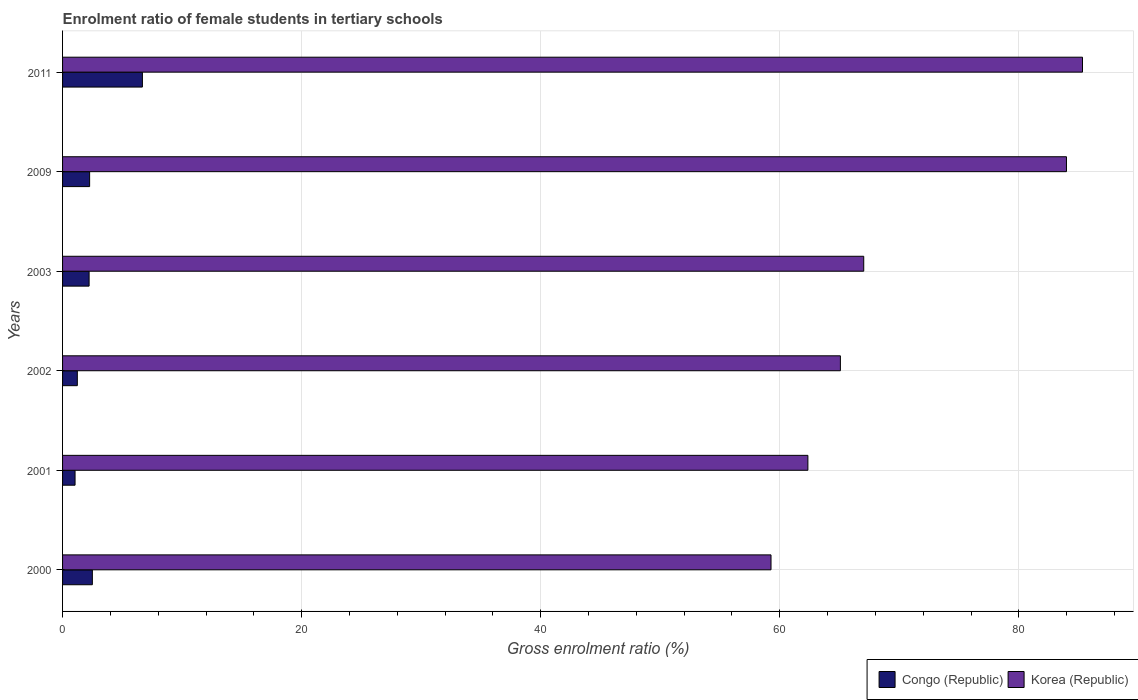How many different coloured bars are there?
Your answer should be compact. 2. How many groups of bars are there?
Your answer should be very brief. 6. Are the number of bars per tick equal to the number of legend labels?
Make the answer very short. Yes. Are the number of bars on each tick of the Y-axis equal?
Keep it short and to the point. Yes. How many bars are there on the 3rd tick from the bottom?
Make the answer very short. 2. What is the label of the 5th group of bars from the top?
Provide a succinct answer. 2001. In how many cases, is the number of bars for a given year not equal to the number of legend labels?
Provide a short and direct response. 0. What is the enrolment ratio of female students in tertiary schools in Congo (Republic) in 2011?
Provide a short and direct response. 6.68. Across all years, what is the maximum enrolment ratio of female students in tertiary schools in Congo (Republic)?
Keep it short and to the point. 6.68. Across all years, what is the minimum enrolment ratio of female students in tertiary schools in Congo (Republic)?
Offer a terse response. 1.04. What is the total enrolment ratio of female students in tertiary schools in Congo (Republic) in the graph?
Offer a terse response. 15.93. What is the difference between the enrolment ratio of female students in tertiary schools in Congo (Republic) in 2000 and that in 2003?
Offer a very short reply. 0.27. What is the difference between the enrolment ratio of female students in tertiary schools in Korea (Republic) in 2009 and the enrolment ratio of female students in tertiary schools in Congo (Republic) in 2003?
Keep it short and to the point. 81.76. What is the average enrolment ratio of female students in tertiary schools in Korea (Republic) per year?
Your response must be concise. 70.5. In the year 2002, what is the difference between the enrolment ratio of female students in tertiary schools in Korea (Republic) and enrolment ratio of female students in tertiary schools in Congo (Republic)?
Your response must be concise. 63.83. What is the ratio of the enrolment ratio of female students in tertiary schools in Korea (Republic) in 2002 to that in 2009?
Keep it short and to the point. 0.77. Is the enrolment ratio of female students in tertiary schools in Congo (Republic) in 2001 less than that in 2009?
Your answer should be compact. Yes. Is the difference between the enrolment ratio of female students in tertiary schools in Korea (Republic) in 2000 and 2009 greater than the difference between the enrolment ratio of female students in tertiary schools in Congo (Republic) in 2000 and 2009?
Your response must be concise. No. What is the difference between the highest and the second highest enrolment ratio of female students in tertiary schools in Congo (Republic)?
Ensure brevity in your answer.  4.19. What is the difference between the highest and the lowest enrolment ratio of female students in tertiary schools in Korea (Republic)?
Your answer should be very brief. 26.06. In how many years, is the enrolment ratio of female students in tertiary schools in Congo (Republic) greater than the average enrolment ratio of female students in tertiary schools in Congo (Republic) taken over all years?
Provide a short and direct response. 1. Is the sum of the enrolment ratio of female students in tertiary schools in Congo (Republic) in 2001 and 2009 greater than the maximum enrolment ratio of female students in tertiary schools in Korea (Republic) across all years?
Provide a succinct answer. No. What does the 2nd bar from the bottom in 2003 represents?
Offer a terse response. Korea (Republic). How many bars are there?
Your response must be concise. 12. How many years are there in the graph?
Keep it short and to the point. 6. What is the difference between two consecutive major ticks on the X-axis?
Give a very brief answer. 20. Are the values on the major ticks of X-axis written in scientific E-notation?
Your answer should be compact. No. Does the graph contain any zero values?
Provide a short and direct response. No. Does the graph contain grids?
Your answer should be very brief. Yes. Where does the legend appear in the graph?
Your answer should be very brief. Bottom right. How many legend labels are there?
Give a very brief answer. 2. How are the legend labels stacked?
Ensure brevity in your answer.  Horizontal. What is the title of the graph?
Provide a succinct answer. Enrolment ratio of female students in tertiary schools. Does "Monaco" appear as one of the legend labels in the graph?
Offer a terse response. No. What is the label or title of the X-axis?
Your answer should be compact. Gross enrolment ratio (%). What is the Gross enrolment ratio (%) in Congo (Republic) in 2000?
Keep it short and to the point. 2.49. What is the Gross enrolment ratio (%) in Korea (Republic) in 2000?
Offer a very short reply. 59.26. What is the Gross enrolment ratio (%) in Congo (Republic) in 2001?
Your answer should be compact. 1.04. What is the Gross enrolment ratio (%) in Korea (Republic) in 2001?
Provide a short and direct response. 62.35. What is the Gross enrolment ratio (%) in Congo (Republic) in 2002?
Offer a terse response. 1.23. What is the Gross enrolment ratio (%) of Korea (Republic) in 2002?
Provide a short and direct response. 65.07. What is the Gross enrolment ratio (%) in Congo (Republic) in 2003?
Make the answer very short. 2.22. What is the Gross enrolment ratio (%) of Korea (Republic) in 2003?
Your answer should be very brief. 67.02. What is the Gross enrolment ratio (%) of Congo (Republic) in 2009?
Provide a succinct answer. 2.26. What is the Gross enrolment ratio (%) of Korea (Republic) in 2009?
Give a very brief answer. 83.98. What is the Gross enrolment ratio (%) of Congo (Republic) in 2011?
Offer a very short reply. 6.68. What is the Gross enrolment ratio (%) in Korea (Republic) in 2011?
Offer a very short reply. 85.32. Across all years, what is the maximum Gross enrolment ratio (%) in Congo (Republic)?
Offer a very short reply. 6.68. Across all years, what is the maximum Gross enrolment ratio (%) of Korea (Republic)?
Give a very brief answer. 85.32. Across all years, what is the minimum Gross enrolment ratio (%) in Congo (Republic)?
Provide a succinct answer. 1.04. Across all years, what is the minimum Gross enrolment ratio (%) of Korea (Republic)?
Provide a succinct answer. 59.26. What is the total Gross enrolment ratio (%) of Congo (Republic) in the graph?
Give a very brief answer. 15.93. What is the total Gross enrolment ratio (%) of Korea (Republic) in the graph?
Give a very brief answer. 423.01. What is the difference between the Gross enrolment ratio (%) of Congo (Republic) in 2000 and that in 2001?
Offer a very short reply. 1.45. What is the difference between the Gross enrolment ratio (%) in Korea (Republic) in 2000 and that in 2001?
Offer a terse response. -3.08. What is the difference between the Gross enrolment ratio (%) of Congo (Republic) in 2000 and that in 2002?
Make the answer very short. 1.26. What is the difference between the Gross enrolment ratio (%) in Korea (Republic) in 2000 and that in 2002?
Keep it short and to the point. -5.8. What is the difference between the Gross enrolment ratio (%) of Congo (Republic) in 2000 and that in 2003?
Your answer should be very brief. 0.27. What is the difference between the Gross enrolment ratio (%) in Korea (Republic) in 2000 and that in 2003?
Provide a short and direct response. -7.76. What is the difference between the Gross enrolment ratio (%) of Congo (Republic) in 2000 and that in 2009?
Provide a short and direct response. 0.23. What is the difference between the Gross enrolment ratio (%) of Korea (Republic) in 2000 and that in 2009?
Your response must be concise. -24.72. What is the difference between the Gross enrolment ratio (%) in Congo (Republic) in 2000 and that in 2011?
Ensure brevity in your answer.  -4.19. What is the difference between the Gross enrolment ratio (%) in Korea (Republic) in 2000 and that in 2011?
Make the answer very short. -26.06. What is the difference between the Gross enrolment ratio (%) of Congo (Republic) in 2001 and that in 2002?
Provide a succinct answer. -0.19. What is the difference between the Gross enrolment ratio (%) in Korea (Republic) in 2001 and that in 2002?
Provide a succinct answer. -2.72. What is the difference between the Gross enrolment ratio (%) in Congo (Republic) in 2001 and that in 2003?
Provide a succinct answer. -1.18. What is the difference between the Gross enrolment ratio (%) in Korea (Republic) in 2001 and that in 2003?
Give a very brief answer. -4.67. What is the difference between the Gross enrolment ratio (%) of Congo (Republic) in 2001 and that in 2009?
Your answer should be very brief. -1.22. What is the difference between the Gross enrolment ratio (%) of Korea (Republic) in 2001 and that in 2009?
Give a very brief answer. -21.63. What is the difference between the Gross enrolment ratio (%) in Congo (Republic) in 2001 and that in 2011?
Your answer should be very brief. -5.63. What is the difference between the Gross enrolment ratio (%) of Korea (Republic) in 2001 and that in 2011?
Keep it short and to the point. -22.97. What is the difference between the Gross enrolment ratio (%) of Congo (Republic) in 2002 and that in 2003?
Keep it short and to the point. -0.99. What is the difference between the Gross enrolment ratio (%) of Korea (Republic) in 2002 and that in 2003?
Offer a terse response. -1.95. What is the difference between the Gross enrolment ratio (%) in Congo (Republic) in 2002 and that in 2009?
Offer a very short reply. -1.03. What is the difference between the Gross enrolment ratio (%) in Korea (Republic) in 2002 and that in 2009?
Provide a succinct answer. -18.91. What is the difference between the Gross enrolment ratio (%) in Congo (Republic) in 2002 and that in 2011?
Offer a terse response. -5.44. What is the difference between the Gross enrolment ratio (%) of Korea (Republic) in 2002 and that in 2011?
Ensure brevity in your answer.  -20.25. What is the difference between the Gross enrolment ratio (%) of Congo (Republic) in 2003 and that in 2009?
Provide a short and direct response. -0.04. What is the difference between the Gross enrolment ratio (%) in Korea (Republic) in 2003 and that in 2009?
Your response must be concise. -16.96. What is the difference between the Gross enrolment ratio (%) in Congo (Republic) in 2003 and that in 2011?
Your response must be concise. -4.46. What is the difference between the Gross enrolment ratio (%) of Korea (Republic) in 2003 and that in 2011?
Ensure brevity in your answer.  -18.3. What is the difference between the Gross enrolment ratio (%) of Congo (Republic) in 2009 and that in 2011?
Offer a terse response. -4.42. What is the difference between the Gross enrolment ratio (%) in Korea (Republic) in 2009 and that in 2011?
Keep it short and to the point. -1.34. What is the difference between the Gross enrolment ratio (%) of Congo (Republic) in 2000 and the Gross enrolment ratio (%) of Korea (Republic) in 2001?
Offer a terse response. -59.86. What is the difference between the Gross enrolment ratio (%) in Congo (Republic) in 2000 and the Gross enrolment ratio (%) in Korea (Republic) in 2002?
Provide a short and direct response. -62.58. What is the difference between the Gross enrolment ratio (%) in Congo (Republic) in 2000 and the Gross enrolment ratio (%) in Korea (Republic) in 2003?
Provide a short and direct response. -64.53. What is the difference between the Gross enrolment ratio (%) in Congo (Republic) in 2000 and the Gross enrolment ratio (%) in Korea (Republic) in 2009?
Offer a terse response. -81.49. What is the difference between the Gross enrolment ratio (%) of Congo (Republic) in 2000 and the Gross enrolment ratio (%) of Korea (Republic) in 2011?
Provide a succinct answer. -82.83. What is the difference between the Gross enrolment ratio (%) of Congo (Republic) in 2001 and the Gross enrolment ratio (%) of Korea (Republic) in 2002?
Provide a short and direct response. -64.02. What is the difference between the Gross enrolment ratio (%) of Congo (Republic) in 2001 and the Gross enrolment ratio (%) of Korea (Republic) in 2003?
Your answer should be compact. -65.98. What is the difference between the Gross enrolment ratio (%) of Congo (Republic) in 2001 and the Gross enrolment ratio (%) of Korea (Republic) in 2009?
Make the answer very short. -82.94. What is the difference between the Gross enrolment ratio (%) of Congo (Republic) in 2001 and the Gross enrolment ratio (%) of Korea (Republic) in 2011?
Offer a very short reply. -84.28. What is the difference between the Gross enrolment ratio (%) of Congo (Republic) in 2002 and the Gross enrolment ratio (%) of Korea (Republic) in 2003?
Provide a short and direct response. -65.79. What is the difference between the Gross enrolment ratio (%) of Congo (Republic) in 2002 and the Gross enrolment ratio (%) of Korea (Republic) in 2009?
Your response must be concise. -82.75. What is the difference between the Gross enrolment ratio (%) in Congo (Republic) in 2002 and the Gross enrolment ratio (%) in Korea (Republic) in 2011?
Give a very brief answer. -84.09. What is the difference between the Gross enrolment ratio (%) in Congo (Republic) in 2003 and the Gross enrolment ratio (%) in Korea (Republic) in 2009?
Keep it short and to the point. -81.76. What is the difference between the Gross enrolment ratio (%) of Congo (Republic) in 2003 and the Gross enrolment ratio (%) of Korea (Republic) in 2011?
Give a very brief answer. -83.1. What is the difference between the Gross enrolment ratio (%) in Congo (Republic) in 2009 and the Gross enrolment ratio (%) in Korea (Republic) in 2011?
Your answer should be compact. -83.06. What is the average Gross enrolment ratio (%) in Congo (Republic) per year?
Your answer should be compact. 2.66. What is the average Gross enrolment ratio (%) in Korea (Republic) per year?
Ensure brevity in your answer.  70.5. In the year 2000, what is the difference between the Gross enrolment ratio (%) of Congo (Republic) and Gross enrolment ratio (%) of Korea (Republic)?
Offer a very short reply. -56.77. In the year 2001, what is the difference between the Gross enrolment ratio (%) in Congo (Republic) and Gross enrolment ratio (%) in Korea (Republic)?
Your response must be concise. -61.3. In the year 2002, what is the difference between the Gross enrolment ratio (%) of Congo (Republic) and Gross enrolment ratio (%) of Korea (Republic)?
Ensure brevity in your answer.  -63.83. In the year 2003, what is the difference between the Gross enrolment ratio (%) of Congo (Republic) and Gross enrolment ratio (%) of Korea (Republic)?
Make the answer very short. -64.8. In the year 2009, what is the difference between the Gross enrolment ratio (%) in Congo (Republic) and Gross enrolment ratio (%) in Korea (Republic)?
Offer a terse response. -81.72. In the year 2011, what is the difference between the Gross enrolment ratio (%) in Congo (Republic) and Gross enrolment ratio (%) in Korea (Republic)?
Make the answer very short. -78.64. What is the ratio of the Gross enrolment ratio (%) in Congo (Republic) in 2000 to that in 2001?
Your answer should be very brief. 2.38. What is the ratio of the Gross enrolment ratio (%) of Korea (Republic) in 2000 to that in 2001?
Your answer should be very brief. 0.95. What is the ratio of the Gross enrolment ratio (%) in Congo (Republic) in 2000 to that in 2002?
Offer a terse response. 2.02. What is the ratio of the Gross enrolment ratio (%) in Korea (Republic) in 2000 to that in 2002?
Your response must be concise. 0.91. What is the ratio of the Gross enrolment ratio (%) of Congo (Republic) in 2000 to that in 2003?
Make the answer very short. 1.12. What is the ratio of the Gross enrolment ratio (%) of Korea (Republic) in 2000 to that in 2003?
Your answer should be compact. 0.88. What is the ratio of the Gross enrolment ratio (%) in Congo (Republic) in 2000 to that in 2009?
Make the answer very short. 1.1. What is the ratio of the Gross enrolment ratio (%) in Korea (Republic) in 2000 to that in 2009?
Your response must be concise. 0.71. What is the ratio of the Gross enrolment ratio (%) of Congo (Republic) in 2000 to that in 2011?
Your answer should be very brief. 0.37. What is the ratio of the Gross enrolment ratio (%) in Korea (Republic) in 2000 to that in 2011?
Make the answer very short. 0.69. What is the ratio of the Gross enrolment ratio (%) of Congo (Republic) in 2001 to that in 2002?
Keep it short and to the point. 0.85. What is the ratio of the Gross enrolment ratio (%) in Korea (Republic) in 2001 to that in 2002?
Keep it short and to the point. 0.96. What is the ratio of the Gross enrolment ratio (%) of Congo (Republic) in 2001 to that in 2003?
Give a very brief answer. 0.47. What is the ratio of the Gross enrolment ratio (%) of Korea (Republic) in 2001 to that in 2003?
Make the answer very short. 0.93. What is the ratio of the Gross enrolment ratio (%) of Congo (Republic) in 2001 to that in 2009?
Your response must be concise. 0.46. What is the ratio of the Gross enrolment ratio (%) of Korea (Republic) in 2001 to that in 2009?
Your answer should be very brief. 0.74. What is the ratio of the Gross enrolment ratio (%) of Congo (Republic) in 2001 to that in 2011?
Give a very brief answer. 0.16. What is the ratio of the Gross enrolment ratio (%) of Korea (Republic) in 2001 to that in 2011?
Your response must be concise. 0.73. What is the ratio of the Gross enrolment ratio (%) in Congo (Republic) in 2002 to that in 2003?
Offer a very short reply. 0.56. What is the ratio of the Gross enrolment ratio (%) in Korea (Republic) in 2002 to that in 2003?
Keep it short and to the point. 0.97. What is the ratio of the Gross enrolment ratio (%) in Congo (Republic) in 2002 to that in 2009?
Provide a short and direct response. 0.55. What is the ratio of the Gross enrolment ratio (%) of Korea (Republic) in 2002 to that in 2009?
Your answer should be compact. 0.77. What is the ratio of the Gross enrolment ratio (%) in Congo (Republic) in 2002 to that in 2011?
Provide a short and direct response. 0.18. What is the ratio of the Gross enrolment ratio (%) in Korea (Republic) in 2002 to that in 2011?
Offer a very short reply. 0.76. What is the ratio of the Gross enrolment ratio (%) in Congo (Republic) in 2003 to that in 2009?
Your answer should be very brief. 0.98. What is the ratio of the Gross enrolment ratio (%) of Korea (Republic) in 2003 to that in 2009?
Offer a very short reply. 0.8. What is the ratio of the Gross enrolment ratio (%) of Congo (Republic) in 2003 to that in 2011?
Offer a very short reply. 0.33. What is the ratio of the Gross enrolment ratio (%) in Korea (Republic) in 2003 to that in 2011?
Your response must be concise. 0.79. What is the ratio of the Gross enrolment ratio (%) in Congo (Republic) in 2009 to that in 2011?
Offer a very short reply. 0.34. What is the ratio of the Gross enrolment ratio (%) of Korea (Republic) in 2009 to that in 2011?
Ensure brevity in your answer.  0.98. What is the difference between the highest and the second highest Gross enrolment ratio (%) of Congo (Republic)?
Make the answer very short. 4.19. What is the difference between the highest and the second highest Gross enrolment ratio (%) in Korea (Republic)?
Your answer should be compact. 1.34. What is the difference between the highest and the lowest Gross enrolment ratio (%) in Congo (Republic)?
Your answer should be compact. 5.63. What is the difference between the highest and the lowest Gross enrolment ratio (%) in Korea (Republic)?
Offer a terse response. 26.06. 